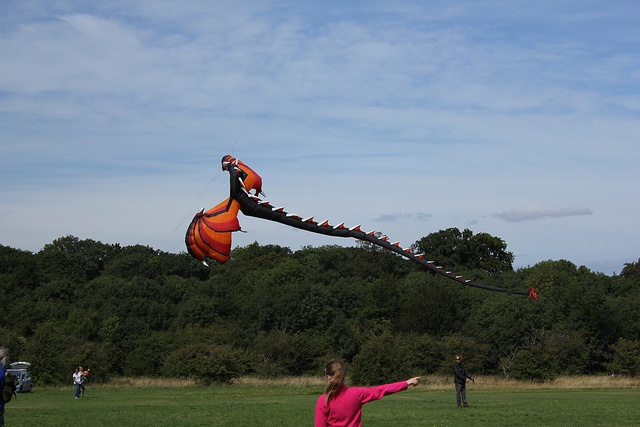Describe the objects in this image and their specific colors. I can see kite in gray, black, brown, maroon, and red tones, people in gray, brown, maroon, and black tones, people in gray, black, darkgreen, and maroon tones, car in gray, black, and purple tones, and people in gray, black, and maroon tones in this image. 